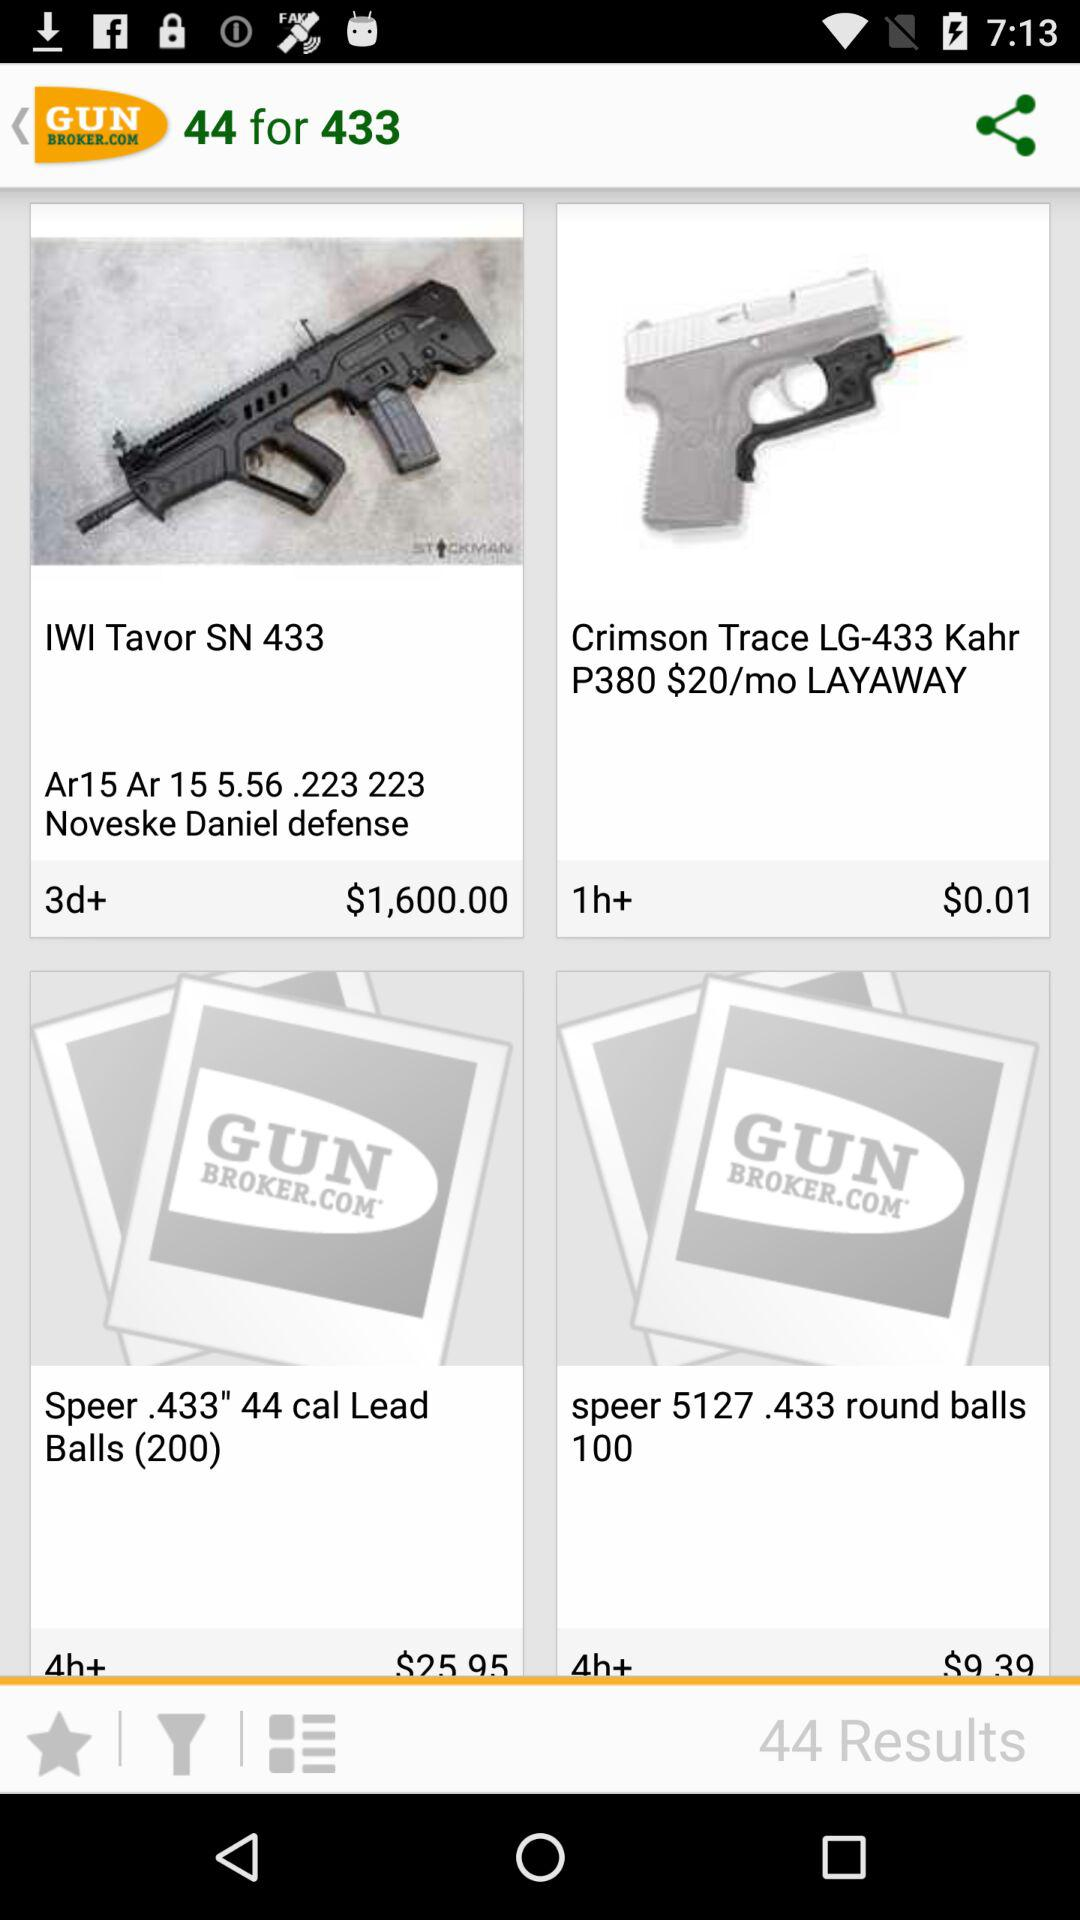How many results are there after searching? There are 44 results after searching. 